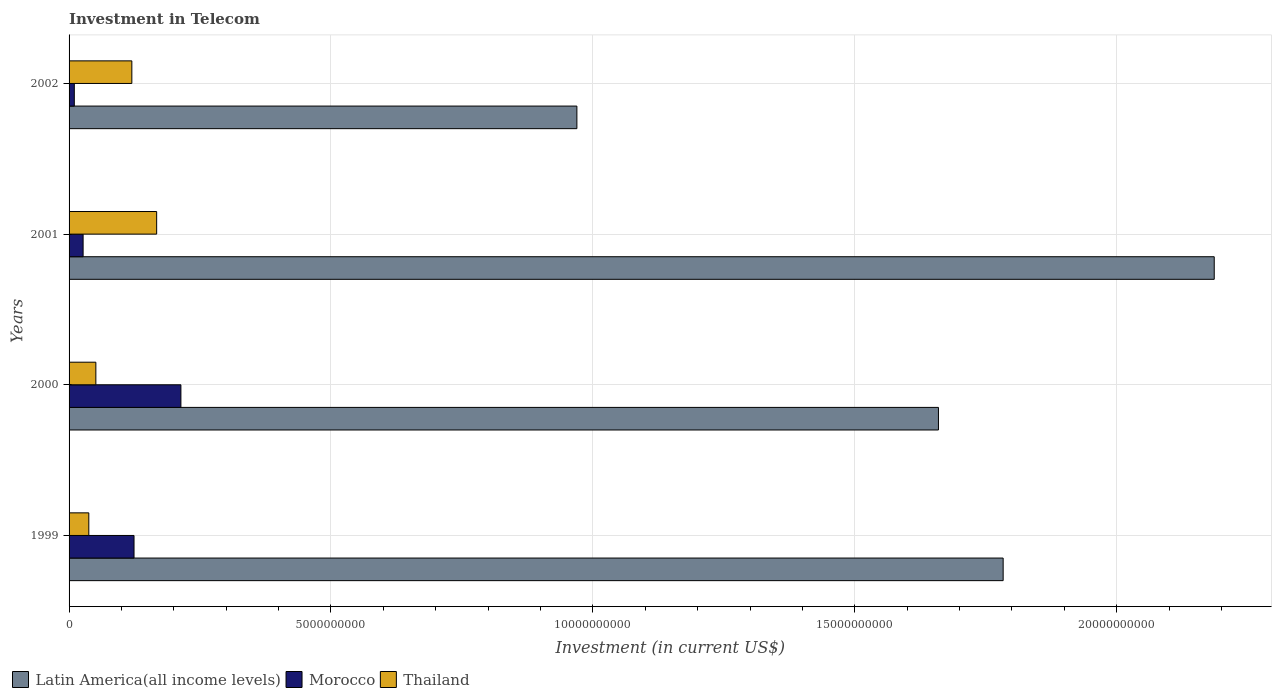How many different coloured bars are there?
Offer a terse response. 3. How many groups of bars are there?
Offer a terse response. 4. Are the number of bars per tick equal to the number of legend labels?
Provide a succinct answer. Yes. Are the number of bars on each tick of the Y-axis equal?
Provide a succinct answer. Yes. In how many cases, is the number of bars for a given year not equal to the number of legend labels?
Make the answer very short. 0. What is the amount invested in telecom in Morocco in 1999?
Offer a terse response. 1.24e+09. Across all years, what is the maximum amount invested in telecom in Thailand?
Offer a very short reply. 1.67e+09. Across all years, what is the minimum amount invested in telecom in Latin America(all income levels)?
Make the answer very short. 9.69e+09. What is the total amount invested in telecom in Thailand in the graph?
Your answer should be very brief. 3.76e+09. What is the difference between the amount invested in telecom in Morocco in 2000 and that in 2001?
Your answer should be compact. 1.87e+09. What is the difference between the amount invested in telecom in Thailand in 2001 and the amount invested in telecom in Latin America(all income levels) in 1999?
Keep it short and to the point. -1.62e+1. What is the average amount invested in telecom in Latin America(all income levels) per year?
Your answer should be compact. 1.65e+1. In the year 2000, what is the difference between the amount invested in telecom in Morocco and amount invested in telecom in Thailand?
Your answer should be compact. 1.62e+09. What is the ratio of the amount invested in telecom in Latin America(all income levels) in 1999 to that in 2002?
Keep it short and to the point. 1.84. Is the amount invested in telecom in Morocco in 1999 less than that in 2000?
Offer a very short reply. Yes. What is the difference between the highest and the second highest amount invested in telecom in Thailand?
Offer a very short reply. 4.74e+08. What is the difference between the highest and the lowest amount invested in telecom in Thailand?
Provide a succinct answer. 1.30e+09. Is the sum of the amount invested in telecom in Thailand in 1999 and 2000 greater than the maximum amount invested in telecom in Morocco across all years?
Your answer should be compact. No. What does the 3rd bar from the top in 2002 represents?
Provide a succinct answer. Latin America(all income levels). What does the 2nd bar from the bottom in 2001 represents?
Your answer should be very brief. Morocco. Are all the bars in the graph horizontal?
Provide a succinct answer. Yes. What is the difference between two consecutive major ticks on the X-axis?
Provide a short and direct response. 5.00e+09. What is the title of the graph?
Provide a succinct answer. Investment in Telecom. What is the label or title of the X-axis?
Your answer should be very brief. Investment (in current US$). What is the Investment (in current US$) of Latin America(all income levels) in 1999?
Provide a succinct answer. 1.78e+1. What is the Investment (in current US$) in Morocco in 1999?
Keep it short and to the point. 1.24e+09. What is the Investment (in current US$) in Thailand in 1999?
Keep it short and to the point. 3.77e+08. What is the Investment (in current US$) in Latin America(all income levels) in 2000?
Provide a short and direct response. 1.66e+1. What is the Investment (in current US$) in Morocco in 2000?
Offer a terse response. 2.14e+09. What is the Investment (in current US$) of Thailand in 2000?
Offer a terse response. 5.11e+08. What is the Investment (in current US$) of Latin America(all income levels) in 2001?
Your answer should be compact. 2.19e+1. What is the Investment (in current US$) of Morocco in 2001?
Give a very brief answer. 2.68e+08. What is the Investment (in current US$) in Thailand in 2001?
Offer a terse response. 1.67e+09. What is the Investment (in current US$) in Latin America(all income levels) in 2002?
Ensure brevity in your answer.  9.69e+09. What is the Investment (in current US$) in Morocco in 2002?
Make the answer very short. 1.00e+08. What is the Investment (in current US$) in Thailand in 2002?
Your answer should be very brief. 1.20e+09. Across all years, what is the maximum Investment (in current US$) of Latin America(all income levels)?
Give a very brief answer. 2.19e+1. Across all years, what is the maximum Investment (in current US$) of Morocco?
Offer a very short reply. 2.14e+09. Across all years, what is the maximum Investment (in current US$) in Thailand?
Give a very brief answer. 1.67e+09. Across all years, what is the minimum Investment (in current US$) in Latin America(all income levels)?
Your response must be concise. 9.69e+09. Across all years, what is the minimum Investment (in current US$) in Thailand?
Your answer should be compact. 3.77e+08. What is the total Investment (in current US$) of Latin America(all income levels) in the graph?
Offer a terse response. 6.60e+1. What is the total Investment (in current US$) in Morocco in the graph?
Provide a short and direct response. 3.74e+09. What is the total Investment (in current US$) in Thailand in the graph?
Give a very brief answer. 3.76e+09. What is the difference between the Investment (in current US$) of Latin America(all income levels) in 1999 and that in 2000?
Give a very brief answer. 1.24e+09. What is the difference between the Investment (in current US$) of Morocco in 1999 and that in 2000?
Your answer should be very brief. -8.95e+08. What is the difference between the Investment (in current US$) of Thailand in 1999 and that in 2000?
Provide a succinct answer. -1.34e+08. What is the difference between the Investment (in current US$) of Latin America(all income levels) in 1999 and that in 2001?
Provide a short and direct response. -4.03e+09. What is the difference between the Investment (in current US$) in Morocco in 1999 and that in 2001?
Provide a short and direct response. 9.72e+08. What is the difference between the Investment (in current US$) of Thailand in 1999 and that in 2001?
Your answer should be compact. -1.30e+09. What is the difference between the Investment (in current US$) of Latin America(all income levels) in 1999 and that in 2002?
Ensure brevity in your answer.  8.14e+09. What is the difference between the Investment (in current US$) of Morocco in 1999 and that in 2002?
Your answer should be compact. 1.14e+09. What is the difference between the Investment (in current US$) of Thailand in 1999 and that in 2002?
Give a very brief answer. -8.21e+08. What is the difference between the Investment (in current US$) in Latin America(all income levels) in 2000 and that in 2001?
Make the answer very short. -5.26e+09. What is the difference between the Investment (in current US$) of Morocco in 2000 and that in 2001?
Make the answer very short. 1.87e+09. What is the difference between the Investment (in current US$) of Thailand in 2000 and that in 2001?
Your response must be concise. -1.16e+09. What is the difference between the Investment (in current US$) of Latin America(all income levels) in 2000 and that in 2002?
Your response must be concise. 6.90e+09. What is the difference between the Investment (in current US$) in Morocco in 2000 and that in 2002?
Your answer should be compact. 2.04e+09. What is the difference between the Investment (in current US$) of Thailand in 2000 and that in 2002?
Keep it short and to the point. -6.87e+08. What is the difference between the Investment (in current US$) of Latin America(all income levels) in 2001 and that in 2002?
Make the answer very short. 1.22e+1. What is the difference between the Investment (in current US$) of Morocco in 2001 and that in 2002?
Ensure brevity in your answer.  1.68e+08. What is the difference between the Investment (in current US$) in Thailand in 2001 and that in 2002?
Make the answer very short. 4.74e+08. What is the difference between the Investment (in current US$) of Latin America(all income levels) in 1999 and the Investment (in current US$) of Morocco in 2000?
Keep it short and to the point. 1.57e+1. What is the difference between the Investment (in current US$) in Latin America(all income levels) in 1999 and the Investment (in current US$) in Thailand in 2000?
Your response must be concise. 1.73e+1. What is the difference between the Investment (in current US$) in Morocco in 1999 and the Investment (in current US$) in Thailand in 2000?
Provide a succinct answer. 7.29e+08. What is the difference between the Investment (in current US$) of Latin America(all income levels) in 1999 and the Investment (in current US$) of Morocco in 2001?
Keep it short and to the point. 1.76e+1. What is the difference between the Investment (in current US$) of Latin America(all income levels) in 1999 and the Investment (in current US$) of Thailand in 2001?
Provide a short and direct response. 1.62e+1. What is the difference between the Investment (in current US$) of Morocco in 1999 and the Investment (in current US$) of Thailand in 2001?
Your response must be concise. -4.32e+08. What is the difference between the Investment (in current US$) in Latin America(all income levels) in 1999 and the Investment (in current US$) in Morocco in 2002?
Provide a short and direct response. 1.77e+1. What is the difference between the Investment (in current US$) of Latin America(all income levels) in 1999 and the Investment (in current US$) of Thailand in 2002?
Offer a terse response. 1.66e+1. What is the difference between the Investment (in current US$) in Morocco in 1999 and the Investment (in current US$) in Thailand in 2002?
Offer a very short reply. 4.18e+07. What is the difference between the Investment (in current US$) of Latin America(all income levels) in 2000 and the Investment (in current US$) of Morocco in 2001?
Provide a short and direct response. 1.63e+1. What is the difference between the Investment (in current US$) in Latin America(all income levels) in 2000 and the Investment (in current US$) in Thailand in 2001?
Your response must be concise. 1.49e+1. What is the difference between the Investment (in current US$) in Morocco in 2000 and the Investment (in current US$) in Thailand in 2001?
Your answer should be very brief. 4.63e+08. What is the difference between the Investment (in current US$) in Latin America(all income levels) in 2000 and the Investment (in current US$) in Morocco in 2002?
Offer a very short reply. 1.65e+1. What is the difference between the Investment (in current US$) in Latin America(all income levels) in 2000 and the Investment (in current US$) in Thailand in 2002?
Your response must be concise. 1.54e+1. What is the difference between the Investment (in current US$) of Morocco in 2000 and the Investment (in current US$) of Thailand in 2002?
Give a very brief answer. 9.37e+08. What is the difference between the Investment (in current US$) in Latin America(all income levels) in 2001 and the Investment (in current US$) in Morocco in 2002?
Offer a very short reply. 2.18e+1. What is the difference between the Investment (in current US$) of Latin America(all income levels) in 2001 and the Investment (in current US$) of Thailand in 2002?
Provide a short and direct response. 2.07e+1. What is the difference between the Investment (in current US$) in Morocco in 2001 and the Investment (in current US$) in Thailand in 2002?
Your response must be concise. -9.30e+08. What is the average Investment (in current US$) in Latin America(all income levels) per year?
Provide a short and direct response. 1.65e+1. What is the average Investment (in current US$) in Morocco per year?
Make the answer very short. 9.36e+08. What is the average Investment (in current US$) of Thailand per year?
Offer a terse response. 9.40e+08. In the year 1999, what is the difference between the Investment (in current US$) in Latin America(all income levels) and Investment (in current US$) in Morocco?
Give a very brief answer. 1.66e+1. In the year 1999, what is the difference between the Investment (in current US$) of Latin America(all income levels) and Investment (in current US$) of Thailand?
Offer a very short reply. 1.75e+1. In the year 1999, what is the difference between the Investment (in current US$) of Morocco and Investment (in current US$) of Thailand?
Your answer should be very brief. 8.63e+08. In the year 2000, what is the difference between the Investment (in current US$) of Latin America(all income levels) and Investment (in current US$) of Morocco?
Your answer should be compact. 1.45e+1. In the year 2000, what is the difference between the Investment (in current US$) of Latin America(all income levels) and Investment (in current US$) of Thailand?
Your answer should be very brief. 1.61e+1. In the year 2000, what is the difference between the Investment (in current US$) in Morocco and Investment (in current US$) in Thailand?
Provide a succinct answer. 1.62e+09. In the year 2001, what is the difference between the Investment (in current US$) in Latin America(all income levels) and Investment (in current US$) in Morocco?
Offer a very short reply. 2.16e+1. In the year 2001, what is the difference between the Investment (in current US$) in Latin America(all income levels) and Investment (in current US$) in Thailand?
Ensure brevity in your answer.  2.02e+1. In the year 2001, what is the difference between the Investment (in current US$) in Morocco and Investment (in current US$) in Thailand?
Keep it short and to the point. -1.40e+09. In the year 2002, what is the difference between the Investment (in current US$) of Latin America(all income levels) and Investment (in current US$) of Morocco?
Ensure brevity in your answer.  9.59e+09. In the year 2002, what is the difference between the Investment (in current US$) in Latin America(all income levels) and Investment (in current US$) in Thailand?
Ensure brevity in your answer.  8.50e+09. In the year 2002, what is the difference between the Investment (in current US$) of Morocco and Investment (in current US$) of Thailand?
Your response must be concise. -1.10e+09. What is the ratio of the Investment (in current US$) in Latin America(all income levels) in 1999 to that in 2000?
Make the answer very short. 1.07. What is the ratio of the Investment (in current US$) of Morocco in 1999 to that in 2000?
Provide a succinct answer. 0.58. What is the ratio of the Investment (in current US$) of Thailand in 1999 to that in 2000?
Your answer should be very brief. 0.74. What is the ratio of the Investment (in current US$) of Latin America(all income levels) in 1999 to that in 2001?
Offer a terse response. 0.82. What is the ratio of the Investment (in current US$) of Morocco in 1999 to that in 2001?
Keep it short and to the point. 4.63. What is the ratio of the Investment (in current US$) in Thailand in 1999 to that in 2001?
Your answer should be very brief. 0.23. What is the ratio of the Investment (in current US$) in Latin America(all income levels) in 1999 to that in 2002?
Provide a short and direct response. 1.84. What is the ratio of the Investment (in current US$) of Morocco in 1999 to that in 2002?
Provide a succinct answer. 12.4. What is the ratio of the Investment (in current US$) of Thailand in 1999 to that in 2002?
Offer a terse response. 0.31. What is the ratio of the Investment (in current US$) in Latin America(all income levels) in 2000 to that in 2001?
Offer a terse response. 0.76. What is the ratio of the Investment (in current US$) of Morocco in 2000 to that in 2001?
Keep it short and to the point. 7.97. What is the ratio of the Investment (in current US$) of Thailand in 2000 to that in 2001?
Offer a terse response. 0.31. What is the ratio of the Investment (in current US$) of Latin America(all income levels) in 2000 to that in 2002?
Give a very brief answer. 1.71. What is the ratio of the Investment (in current US$) of Morocco in 2000 to that in 2002?
Offer a terse response. 21.35. What is the ratio of the Investment (in current US$) in Thailand in 2000 to that in 2002?
Provide a short and direct response. 0.43. What is the ratio of the Investment (in current US$) in Latin America(all income levels) in 2001 to that in 2002?
Your response must be concise. 2.26. What is the ratio of the Investment (in current US$) in Morocco in 2001 to that in 2002?
Offer a terse response. 2.68. What is the ratio of the Investment (in current US$) of Thailand in 2001 to that in 2002?
Ensure brevity in your answer.  1.4. What is the difference between the highest and the second highest Investment (in current US$) of Latin America(all income levels)?
Make the answer very short. 4.03e+09. What is the difference between the highest and the second highest Investment (in current US$) in Morocco?
Ensure brevity in your answer.  8.95e+08. What is the difference between the highest and the second highest Investment (in current US$) of Thailand?
Your response must be concise. 4.74e+08. What is the difference between the highest and the lowest Investment (in current US$) in Latin America(all income levels)?
Ensure brevity in your answer.  1.22e+1. What is the difference between the highest and the lowest Investment (in current US$) of Morocco?
Your response must be concise. 2.04e+09. What is the difference between the highest and the lowest Investment (in current US$) in Thailand?
Provide a succinct answer. 1.30e+09. 